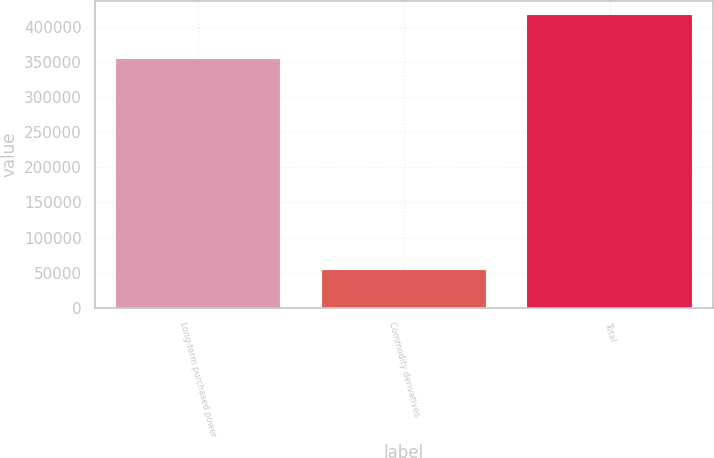<chart> <loc_0><loc_0><loc_500><loc_500><bar_chart><fcel>Long-term purchased power<fcel>Commodity derivatives<fcel>Total<nl><fcel>353531<fcel>54307<fcel>416341<nl></chart> 